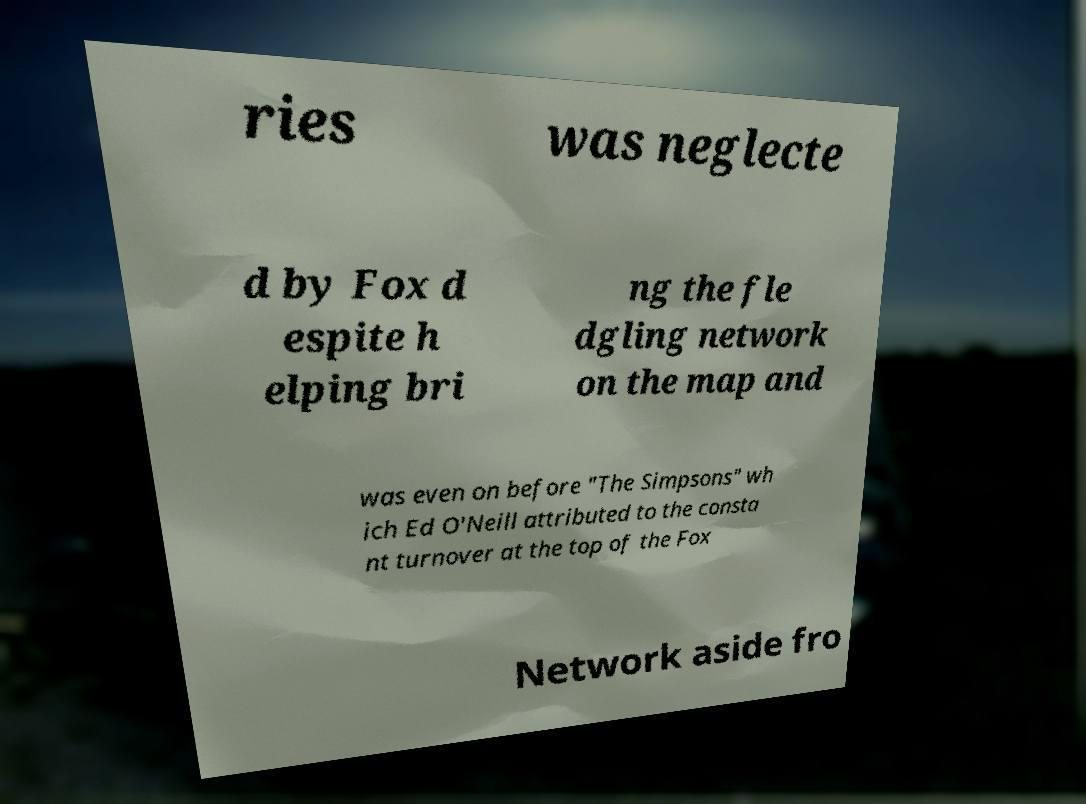Can you accurately transcribe the text from the provided image for me? ries was neglecte d by Fox d espite h elping bri ng the fle dgling network on the map and was even on before "The Simpsons" wh ich Ed O'Neill attributed to the consta nt turnover at the top of the Fox Network aside fro 